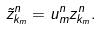<formula> <loc_0><loc_0><loc_500><loc_500>\tilde { z } _ { k _ { m } } ^ { n } = { u } _ { m } ^ { n } { z } _ { k _ { m } } ^ { n } .</formula> 